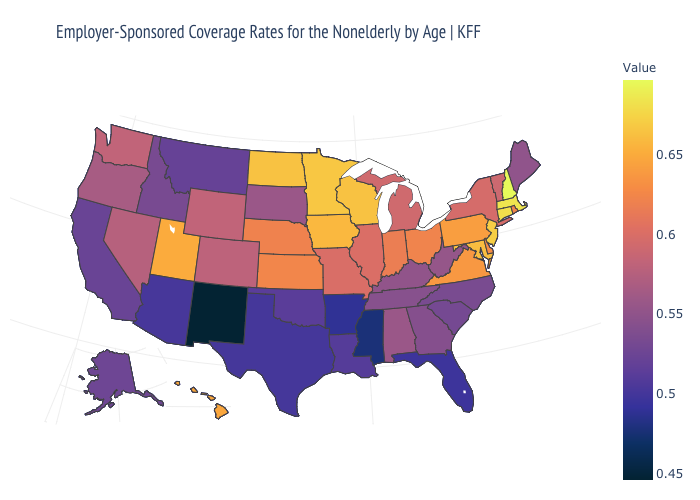Which states have the highest value in the USA?
Be succinct. New Hampshire. Does New Mexico have the lowest value in the West?
Give a very brief answer. Yes. Is the legend a continuous bar?
Concise answer only. Yes. Does New Mexico have the lowest value in the USA?
Give a very brief answer. Yes. Does Oklahoma have a higher value than New Mexico?
Quick response, please. Yes. Which states have the lowest value in the MidWest?
Keep it brief. South Dakota. Does New Mexico have the lowest value in the USA?
Be succinct. Yes. 